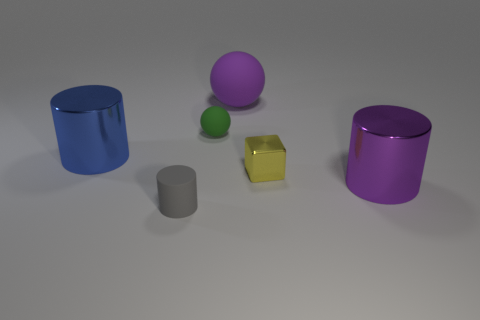Add 1 purple matte things. How many objects exist? 7 Subtract all balls. How many objects are left? 4 Add 5 yellow things. How many yellow things are left? 6 Add 1 large blue cylinders. How many large blue cylinders exist? 2 Subtract 0 gray blocks. How many objects are left? 6 Subtract all tiny spheres. Subtract all small metal blocks. How many objects are left? 4 